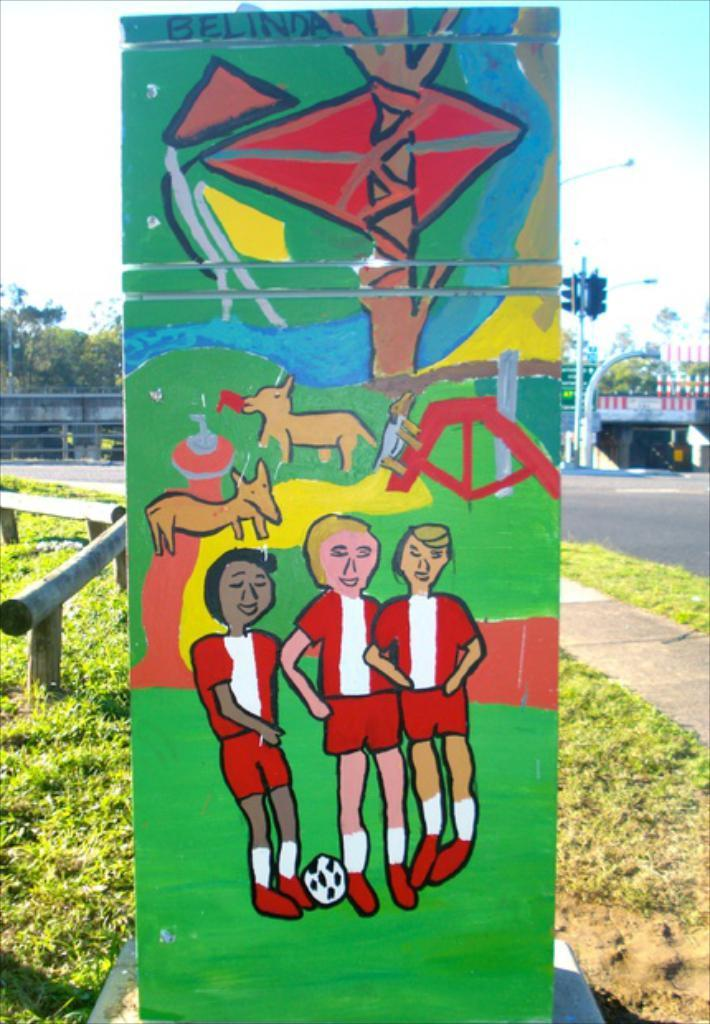What is the main subject in the front portion of the image? There is a painting in the front portion of the image. What can be seen in the background of the image? In the background of the image, there are signal lights, poles, signboards, a hoarding, trees, grass, and the sky. Can you describe the objects in the background related to transportation? In the background of the image, there are signal lights and poles, which are related to transportation. What type of natural elements are visible in the background of the image? In the background of the image, trees and grass are visible, which are natural elements. How does the wind affect the growth of the painting in the image? The painting is not a living organism, so it does not grow, and wind does not affect it. 